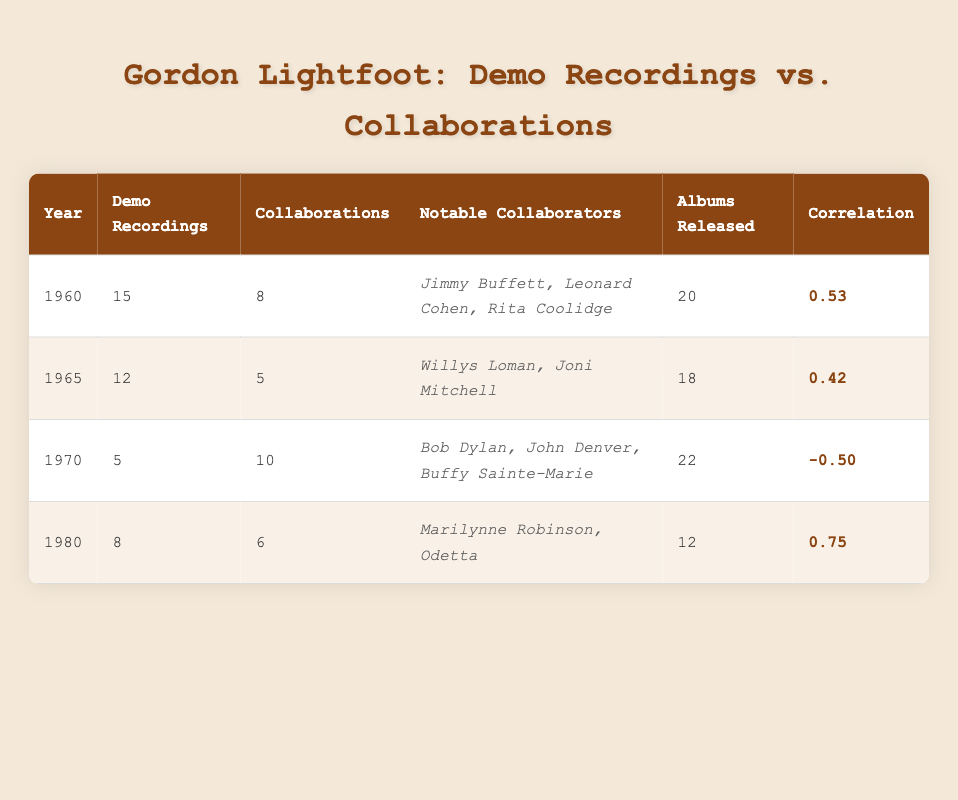What is the total number of demo recordings across all years? To find the total number of demo recordings, we add up the demo recordings from all years: 15 + 12 + 5 + 8 = 40.
Answer: 40 Which year had the highest number of collaborations? Looking at the collaborations column, the year 1970 has the highest number of collaborations, which is 10.
Answer: 1970 What is the correlation value for the year 1980? From the table, the correlation value for the year 1980 is listed as 0.75.
Answer: 0.75 Did any year have more demo recordings than collaborations? Checking the records: in 1960 (15 vs 8), 1965 (12 vs 5), and 1980 (8 vs 6) had more demo recordings than collaborations. In 1970, there were more collaborations (10) than demo recordings (5). Thus, the answer is yes for 1960, 1965, and 1980.
Answer: Yes What is the average number of demo recordings across all years? We calculate the average by adding the demo recordings (15 + 12 + 5 + 8 = 40) and dividing by the number of years (4), resulting in an average of 40 / 4 = 10.
Answer: 10 How many albums were released in the year with the most notable collaborators? The year 1970 has the most notable collaborators (3: Bob Dylan, John Denver, Buffy Sainte-Marie). According to the table, 22 albums were released that year.
Answer: 22 Is there a year where the number of collaborations is greater than the number of demo recordings? By examining the table, the year 1970 shows 10 collaborations against only 5 demo recordings. Hence, the answer is yes for that year.
Answer: Yes What is the difference in demo recordings between the years 1960 and 1980? We find the demo recordings for 1960 (15) and 1980 (8) and calculate the difference: 15 - 8 = 7.
Answer: 7 Which year has a correlation value below zero? Looking at the correlation values, only the year 1970 has a correlation value of -0.50, which is below zero.
Answer: 1970 